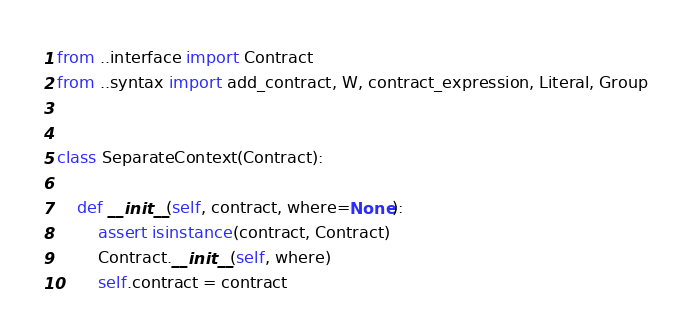Convert code to text. <code><loc_0><loc_0><loc_500><loc_500><_Python_>from ..interface import Contract
from ..syntax import add_contract, W, contract_expression, Literal, Group


class SeparateContext(Contract):

    def __init__(self, contract, where=None):
        assert isinstance(contract, Contract)
        Contract.__init__(self, where)
        self.contract = contract
</code> 